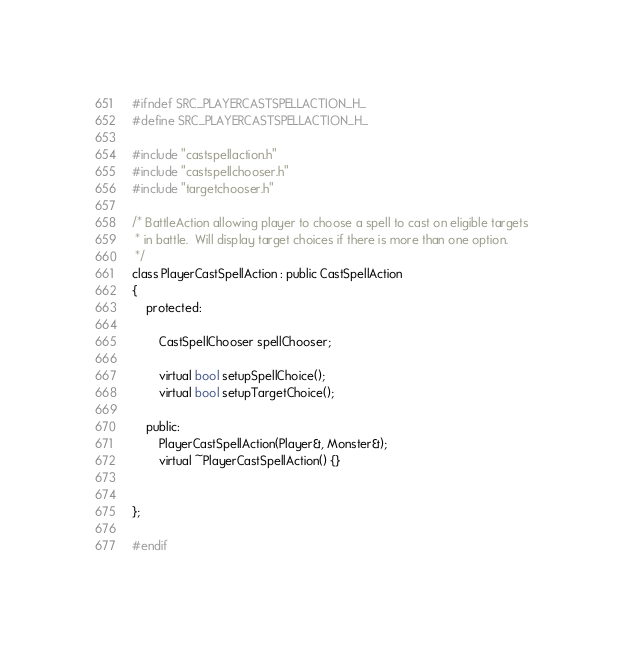<code> <loc_0><loc_0><loc_500><loc_500><_C_>#ifndef SRC_PLAYERCASTSPELLACTION_H_
#define SRC_PLAYERCASTSPELLACTION_H_

#include "castspellaction.h"
#include "castspellchooser.h"
#include "targetchooser.h"

/* BattleAction allowing player to choose a spell to cast on eligible targets
 * in battle.  Will display target choices if there is more than one option.
 */
class PlayerCastSpellAction : public CastSpellAction
{
	protected:

		CastSpellChooser spellChooser;

		virtual bool setupSpellChoice();
		virtual bool setupTargetChoice();

	public:
		PlayerCastSpellAction(Player&, Monster&);
		virtual ~PlayerCastSpellAction() {}


};

#endif
</code> 